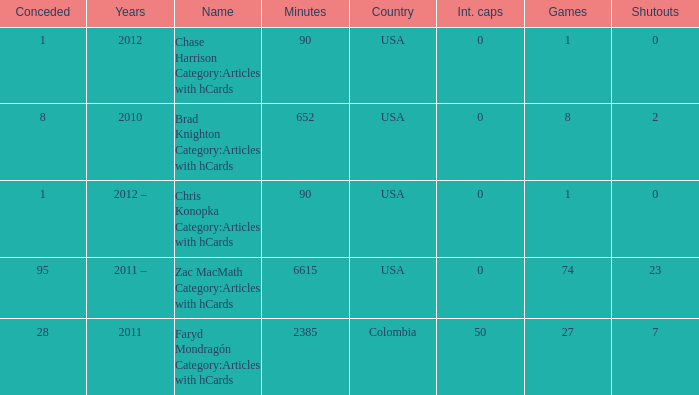When 2010 is the year what is the game? 8.0. 